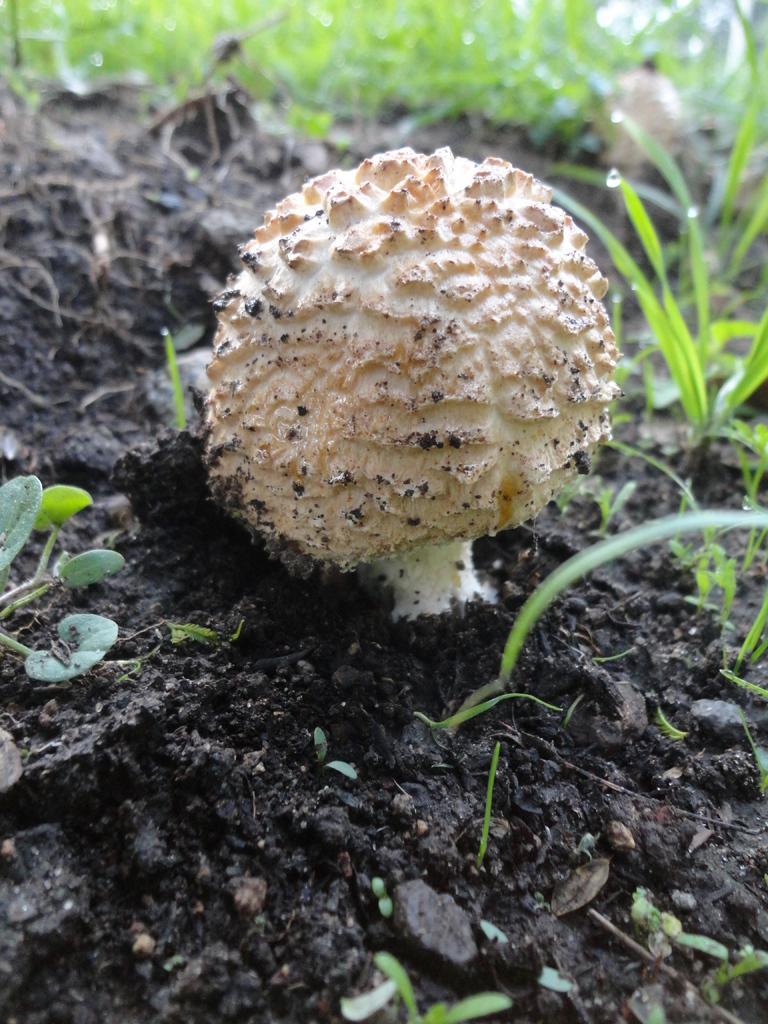Could you give a brief overview of what you see in this image? In the image there is a mushroom on the land with grass behind it. 